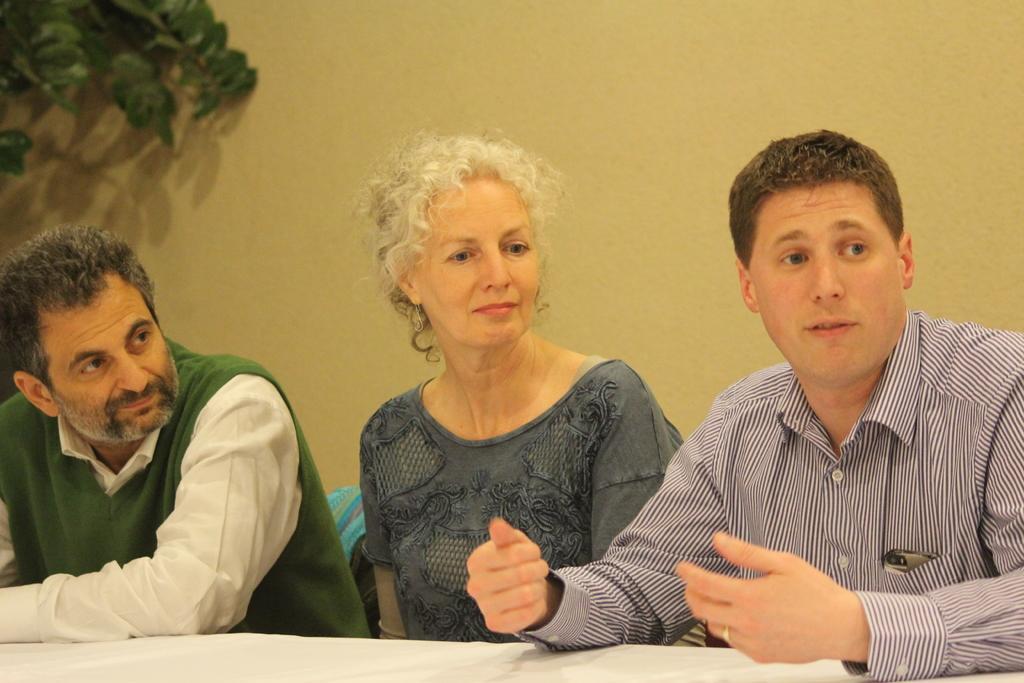In one or two sentences, can you explain what this image depicts? In this picture we can see people are sitting and in-front of them there is a table. Background there is a wall and green leaves. 